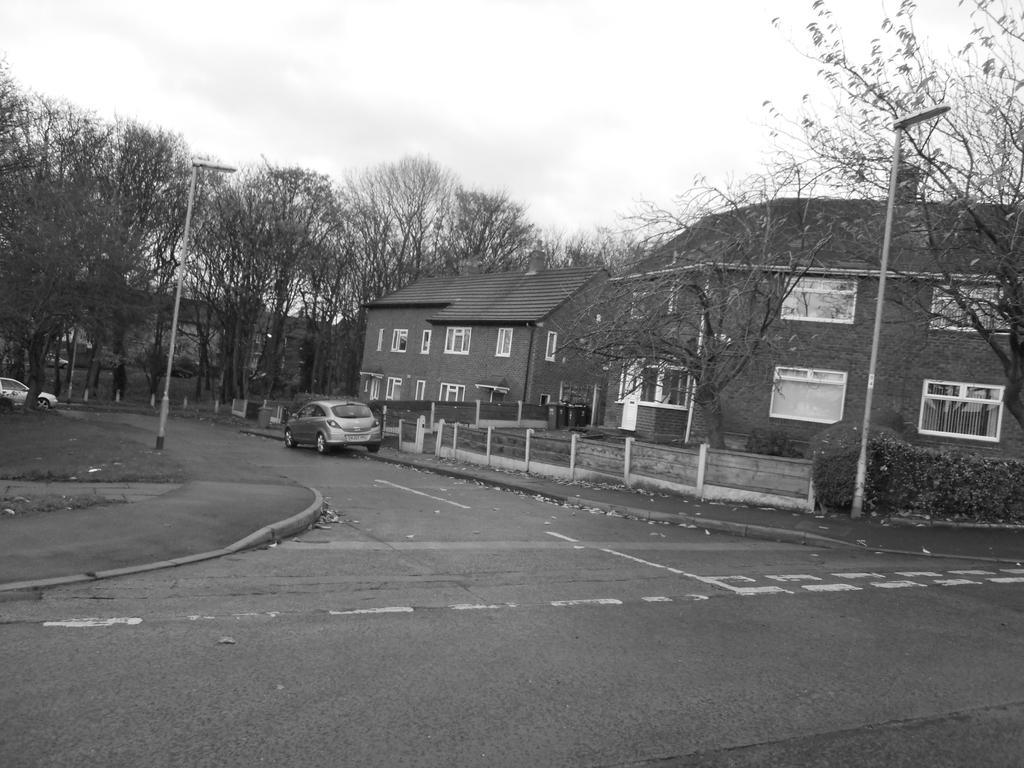In one or two sentences, can you explain what this image depicts? In this image in the background there are buildings, trees. In the road there are cars. There is boundary around the building. 